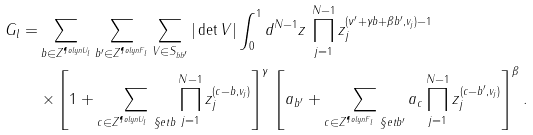<formula> <loc_0><loc_0><loc_500><loc_500>G _ { l } = & \sum _ { b \in Z ^ { \P o l y n { U } _ { l } } } \sum _ { b ^ { \prime } \in Z ^ { \P o l y n { F } _ { l } } } \sum _ { V \in S _ { b b ^ { \prime } } } | \det V | \int _ { 0 } ^ { 1 } d ^ { N - 1 } z \, \prod _ { j = 1 } ^ { N - 1 } z _ { j } ^ { ( \nu ^ { \prime } + \gamma b + \beta b ^ { \prime } , v _ { j } ) - 1 } \, \\ & \times \left [ 1 + \sum _ { c \in Z ^ { \P o l y n { U } _ { l } } \ \S e t { b } } \prod _ { j = 1 } ^ { N - 1 } z _ { j } ^ { ( c - b , v _ { j } ) } \right ] ^ { \gamma } \, \left [ { a } _ { b ^ { \prime } } + \sum _ { c \in Z ^ { \P o l y n { F } _ { l } } \ \S e t { b ^ { \prime } } } { a } _ { c } \prod _ { j = 1 } ^ { N - 1 } z _ { j } ^ { ( c - b ^ { \prime } , v _ { j } ) } \right ] ^ { \beta } .</formula> 